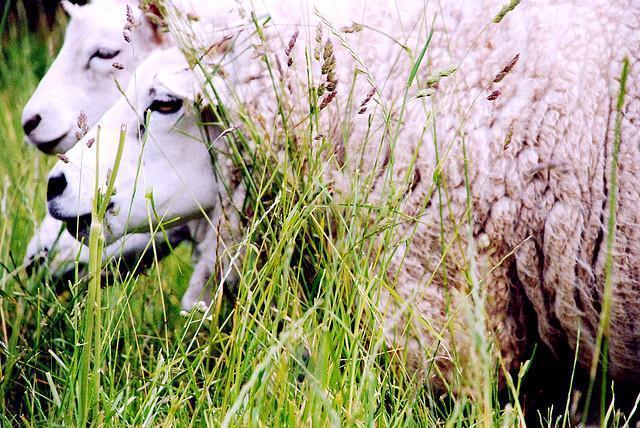How many sheep are there?
Give a very brief answer. 3. How many lamb are in the field?
Give a very brief answer. 3. How many sheep are in the photo?
Give a very brief answer. 3. 